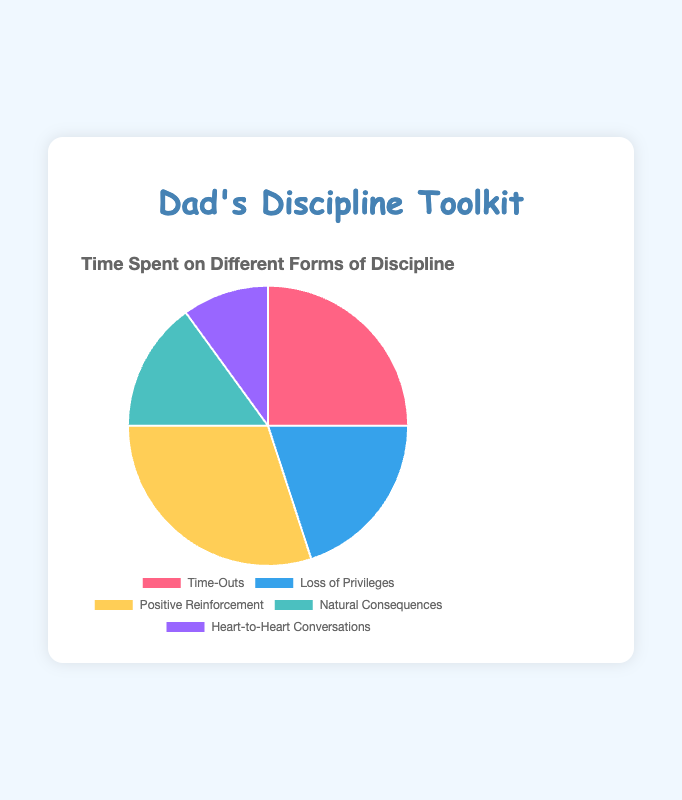What percentage of the pie chart is represented by "Positive Reinforcement"? "Positive Reinforcement" occupies 30% of the pie chart, as stated in the data.
Answer: 30% Which method of discipline is used the most? The segment with the highest percentage corresponds to "Positive Reinforcement," which has 30%.
Answer: Positive Reinforcement Is "Time-Outs" used more or less than "Loss of Privileges"? "Time-Outs" has 25%, whereas "Loss of Privileges" has 20%, thus "Time-Outs" is used more.
Answer: More What is the sum of the percentages for "Natural Consequences" and "Heart-to-Heart Conversations"? "Natural Consequences" is 15% and "Heart-to-Heart Conversations" is 10%. Adding them up gives 15% + 10% = 25%.
Answer: 25% Which color represents "Time-Outs" in the pie chart? "Time-Outs" is represented by the first color listed, which is red.
Answer: Red Are "Heart-to-Heart Conversations" used more frequently than "Natural Consequences"? "Heart-to-Heart Conversations" has 10%, which is less than "Natural Consequences" at 15%.
Answer: Less What is the difference in percentage points between "Positive Reinforcement" and "Time-Outs"? "Positive Reinforcement" is 30% and "Time-Outs" is 25%. The difference is 30% - 25% = 5%.
Answer: 5% If "Loss of Privileges" and "Natural Consequences" were combined into a single category, what percentage would that be? "Loss of Privileges" is 20% and "Natural Consequences" is 15%. Combined, they would be 20% + 15% = 35%.
Answer: 35% Which discipline method takes up the smallest segment of the pie chart? "Heart-to-Heart Conversations" has the smallest percentage at 10%.
Answer: Heart-to-Heart Conversations 